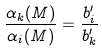<formula> <loc_0><loc_0><loc_500><loc_500>\frac { \alpha _ { k } ( M ) } { \alpha _ { i } ( M ) } = \frac { b ^ { \prime } _ { i } } { b ^ { \prime } _ { k } }</formula> 